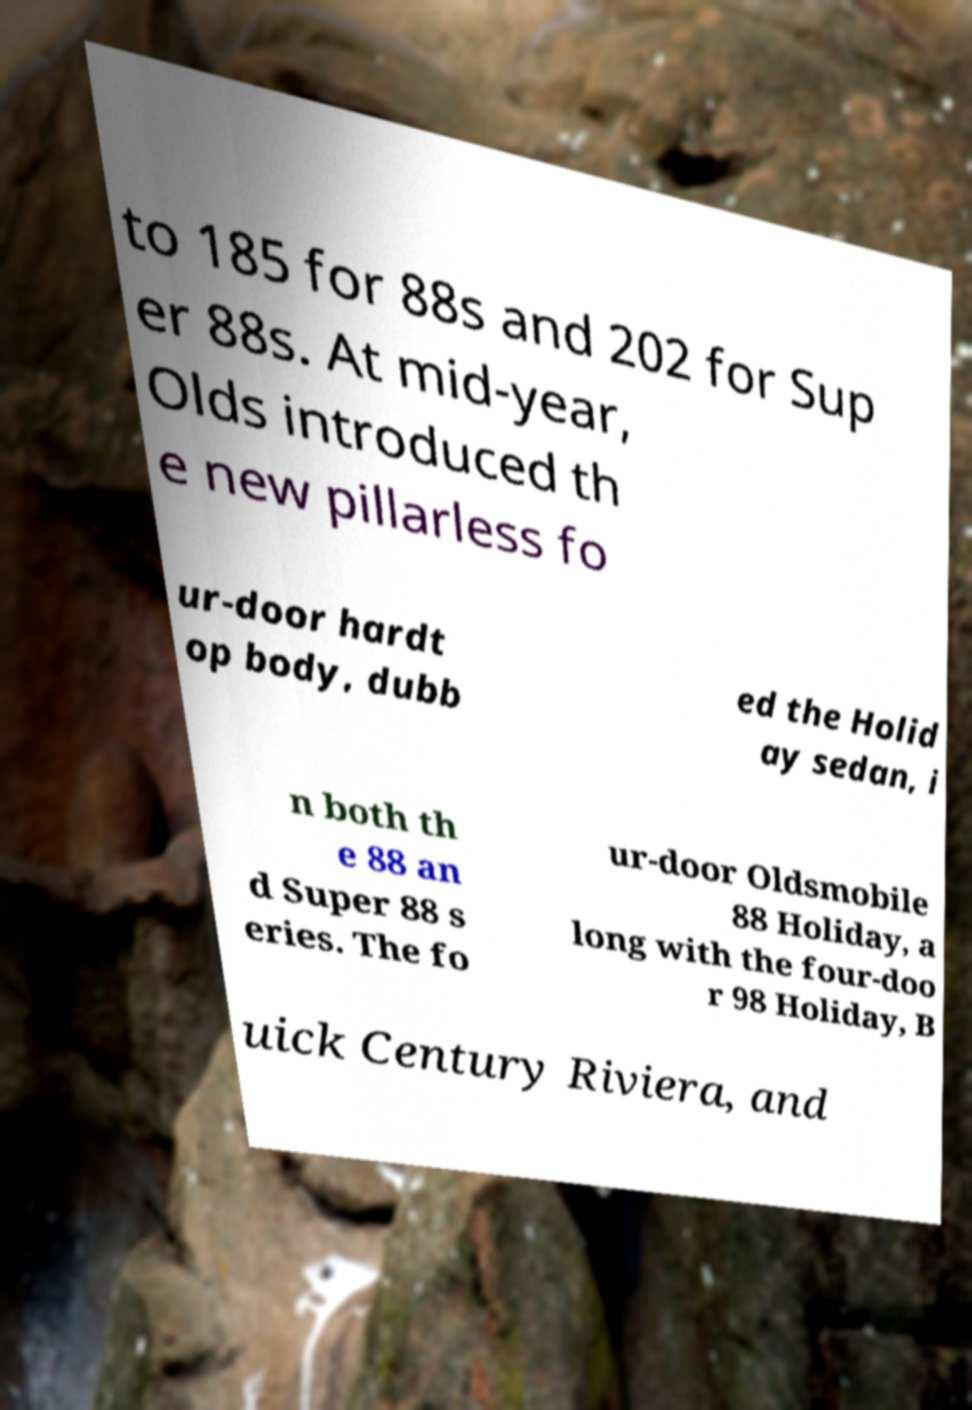What messages or text are displayed in this image? I need them in a readable, typed format. to 185 for 88s and 202 for Sup er 88s. At mid-year, Olds introduced th e new pillarless fo ur-door hardt op body, dubb ed the Holid ay sedan, i n both th e 88 an d Super 88 s eries. The fo ur-door Oldsmobile 88 Holiday, a long with the four-doo r 98 Holiday, B uick Century Riviera, and 